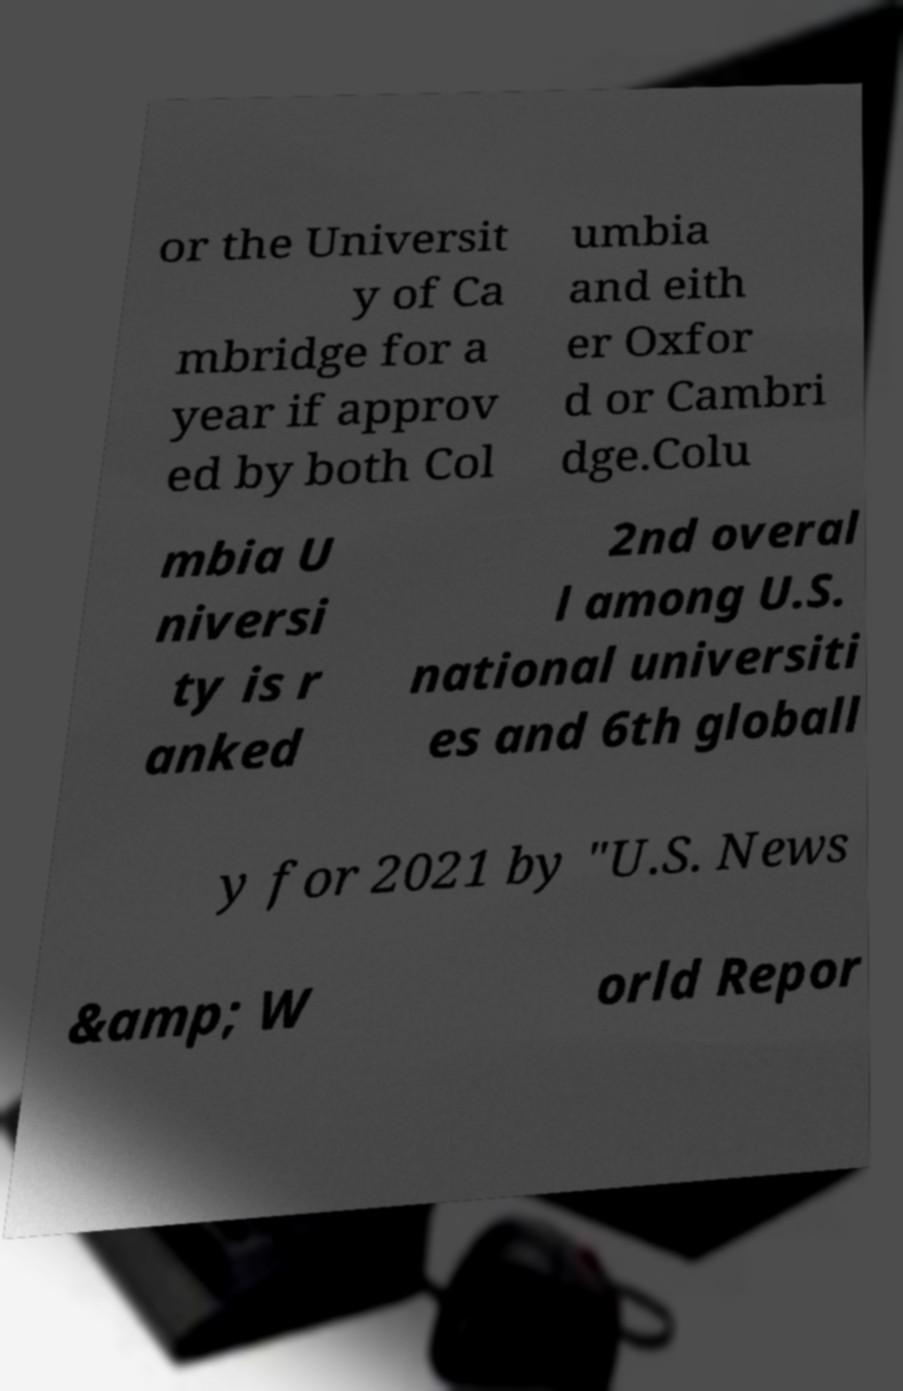Could you extract and type out the text from this image? or the Universit y of Ca mbridge for a year if approv ed by both Col umbia and eith er Oxfor d or Cambri dge.Colu mbia U niversi ty is r anked 2nd overal l among U.S. national universiti es and 6th globall y for 2021 by "U.S. News &amp; W orld Repor 